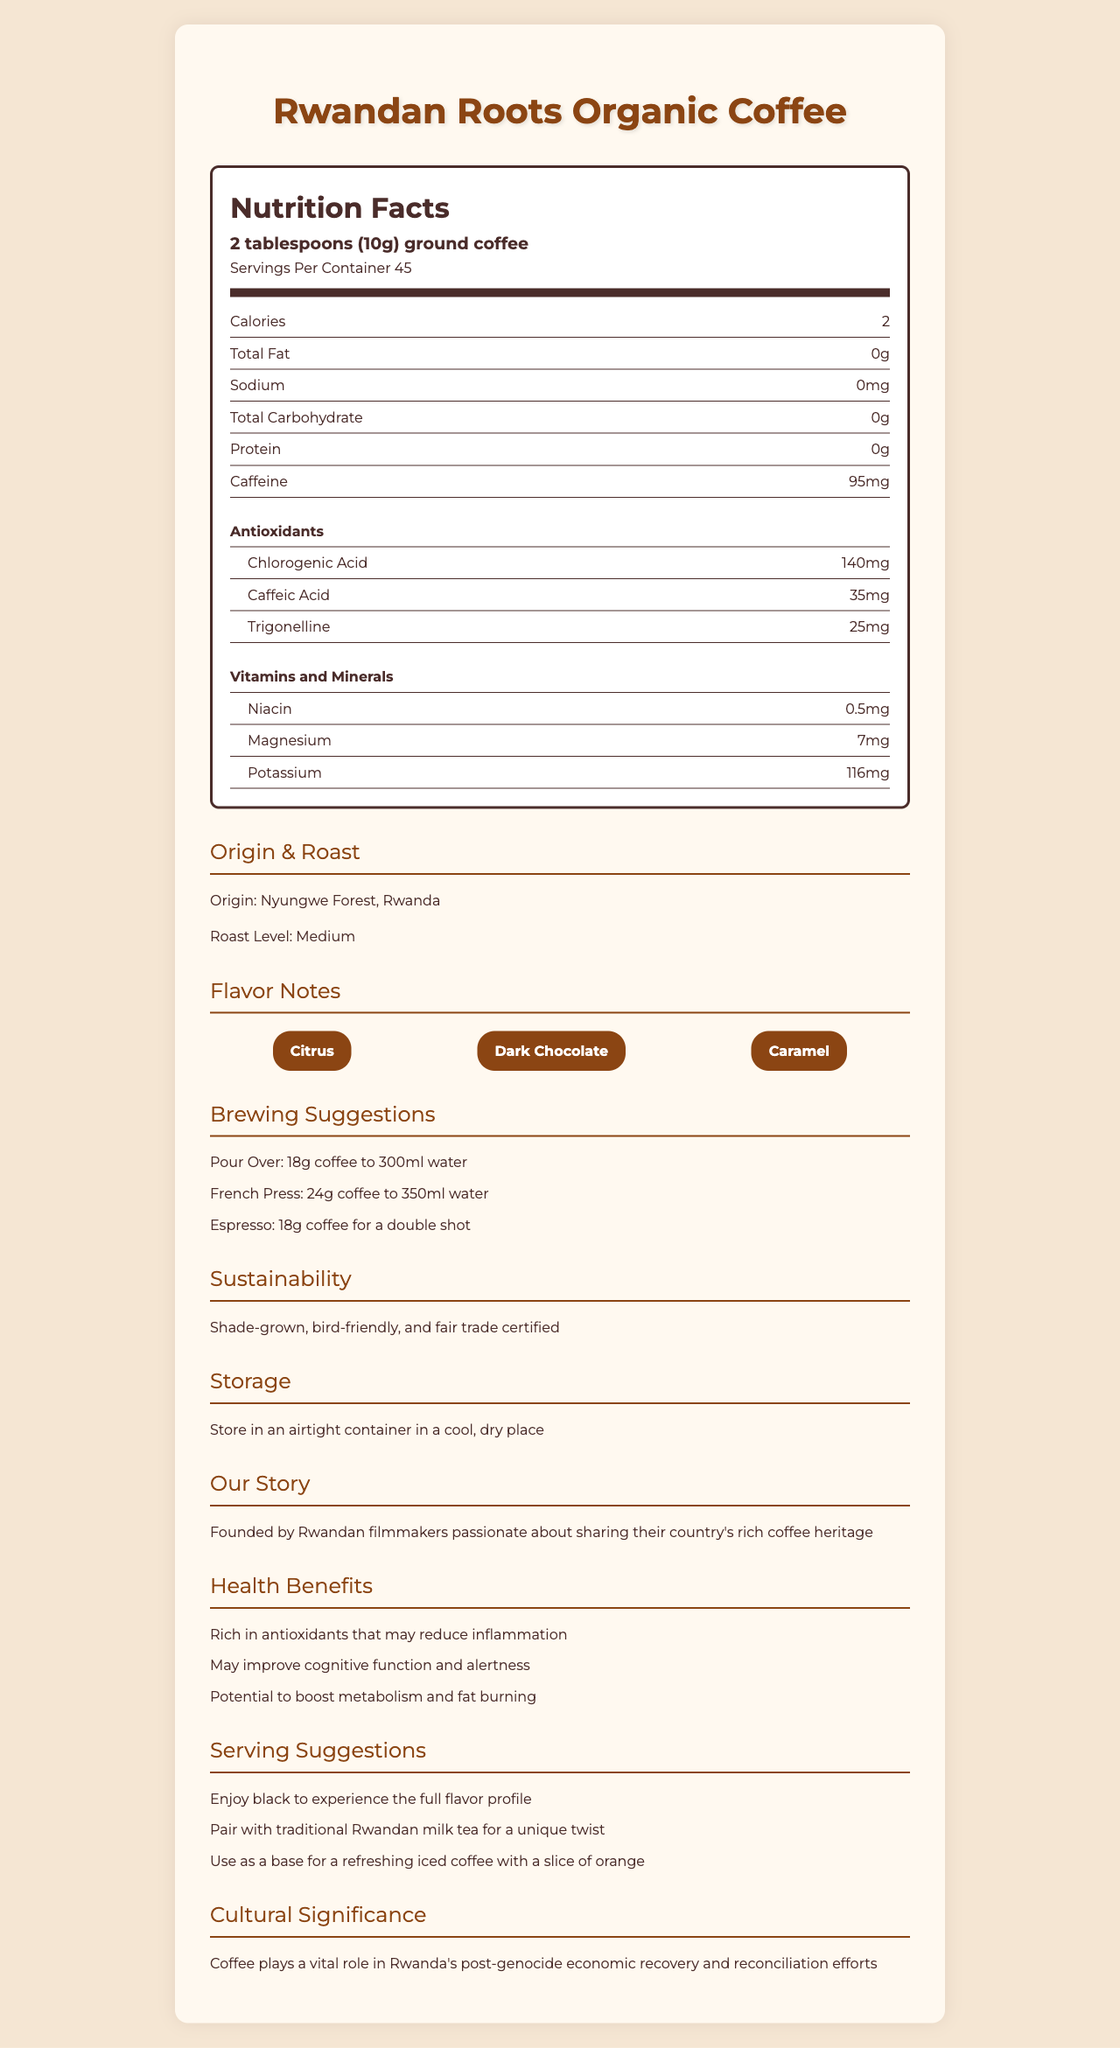what is the serving size for Rwandan Roots Organic Coffee? The document specifies the serving size as "2 tablespoons (10g) ground coffee".
Answer: 2 tablespoons (10g) ground coffee how many calories are there per serving? The document mentions that there are 2 calories per serving.
Answer: 2 how much caffeine does one serving contain? According to the document, one serving of the coffee contains 95mg of caffeine.
Answer: 95mg name two antioxidants found in Rwandan Roots Organic Coffee. The document lists chlorogenic acid (140mg) and caffeic acid (35mg) as antioxidants present in the coffee.
Answer: Chlorogenic acid and caffeic acid which minerals are present in the coffee, and their amounts? The document provides this information under the vitamins and minerals section.
Answer: Niacin (0.5mg), Magnesium (7mg), and Potassium (116mg) The coffee comes from which forest in Rwanda? The document states that the origin of the coffee is Nyungwe Forest in Rwanda.
Answer: Nyungwe Forest multiple-choice: what are the flavor notes of Rwandan Roots Organic Coffee? A. Fruity, Nutty, Spicy B. Citrus, Dark Chocolate, Caramel C. Floral, Earthy, Sweet D. Nutty, Spicy, Caramel The document mentions that the flavor notes are Citrus, Dark Chocolate, and Caramel.
Answer: B multiple-choice: which brewing suggestion correctly matches the coffee to the water ratio? i. Pour Over: 24g coffee to 350ml water ii. French Press: 18g coffee to 300ml water iii. Espresso: 18g coffee for a double shot iv. Pour Over: 18g coffee to 300ml water The document specifies, "Pour Over: 18g coffee to 300ml water".
Answer: iv true/false: The document indicates that the coffee beans are fair trade certified. The document mentions that the coffee is fair trade certified under sustainability info.
Answer: True summarize the information provided in the document. The document outlines various aspects such as nutritional content, antioxidants, the origin of the coffee, recommended brewing methods, sustainability practices, health benefits, and cultural importance of coffee in Rwanda.
Answer: The document provides detailed information about Rwandan Roots Organic Coffee, including its nutrition facts, origin, flavor notes, antioxidants, vitamins, and minerals. It also includes brewing suggestions, sustainability information, storage instructions, company story, health benefits, and cultural significance of coffee in Rwanda. what is the total fat content in one serving of Rwandan Roots Organic Coffee? The document specifies that the total fat content per serving is 0g.
Answer: 0g how should one store Rwandan Roots Organic Coffee for maximum freshness? The storage instructions in the document recommend keeping the coffee in an airtight container in a cool, dry place.
Answer: Store in an airtight container in a cool, dry place what is the role of coffee in Rwanda's post-genocide efforts? The document states that coffee is significant in Rwanda's post-genocide economic recovery and reconciliation efforts.
Answer: Coffee plays a vital role in Rwanda's post-genocide economic recovery and reconciliation efforts. how many servings are in one container of Rwandan Roots Organic Coffee? The document mentions that there are 45 servings per container.
Answer: 45 which brewing suggestion does NOT appear in the document? A. Pour Over B. French Press C. Cold Brew D. Espresso The document does not mention Cold Brew; the brewing suggestions listed are Pour Over, French Press, and Espresso.
Answer: C what are the health benefits of consuming this coffee? The document lists these health benefits in the health benefits section.
Answer: Rich in antioxidants, may improve cognitive function and alertness, potential to boost metabolism and fat burning which antioxidants are present in the highest amount in the coffee? The document lists chlorogenic acid as having the highest amount among the antioxidants, at 140mg.
Answer: Chlorogenic acid (140mg) what is the main idea behind the founders of Rwandan Roots Organic Coffee? The document notes that the founders are Rwandan filmmakers passionate about sharing their country's rich coffee heritage.
Answer: Sharing Rwanda's rich coffee heritage as Rwandan filmmakers. when was the company founded? The document does not provide a specific date or year for when the company was founded.
Answer: Not enough information 